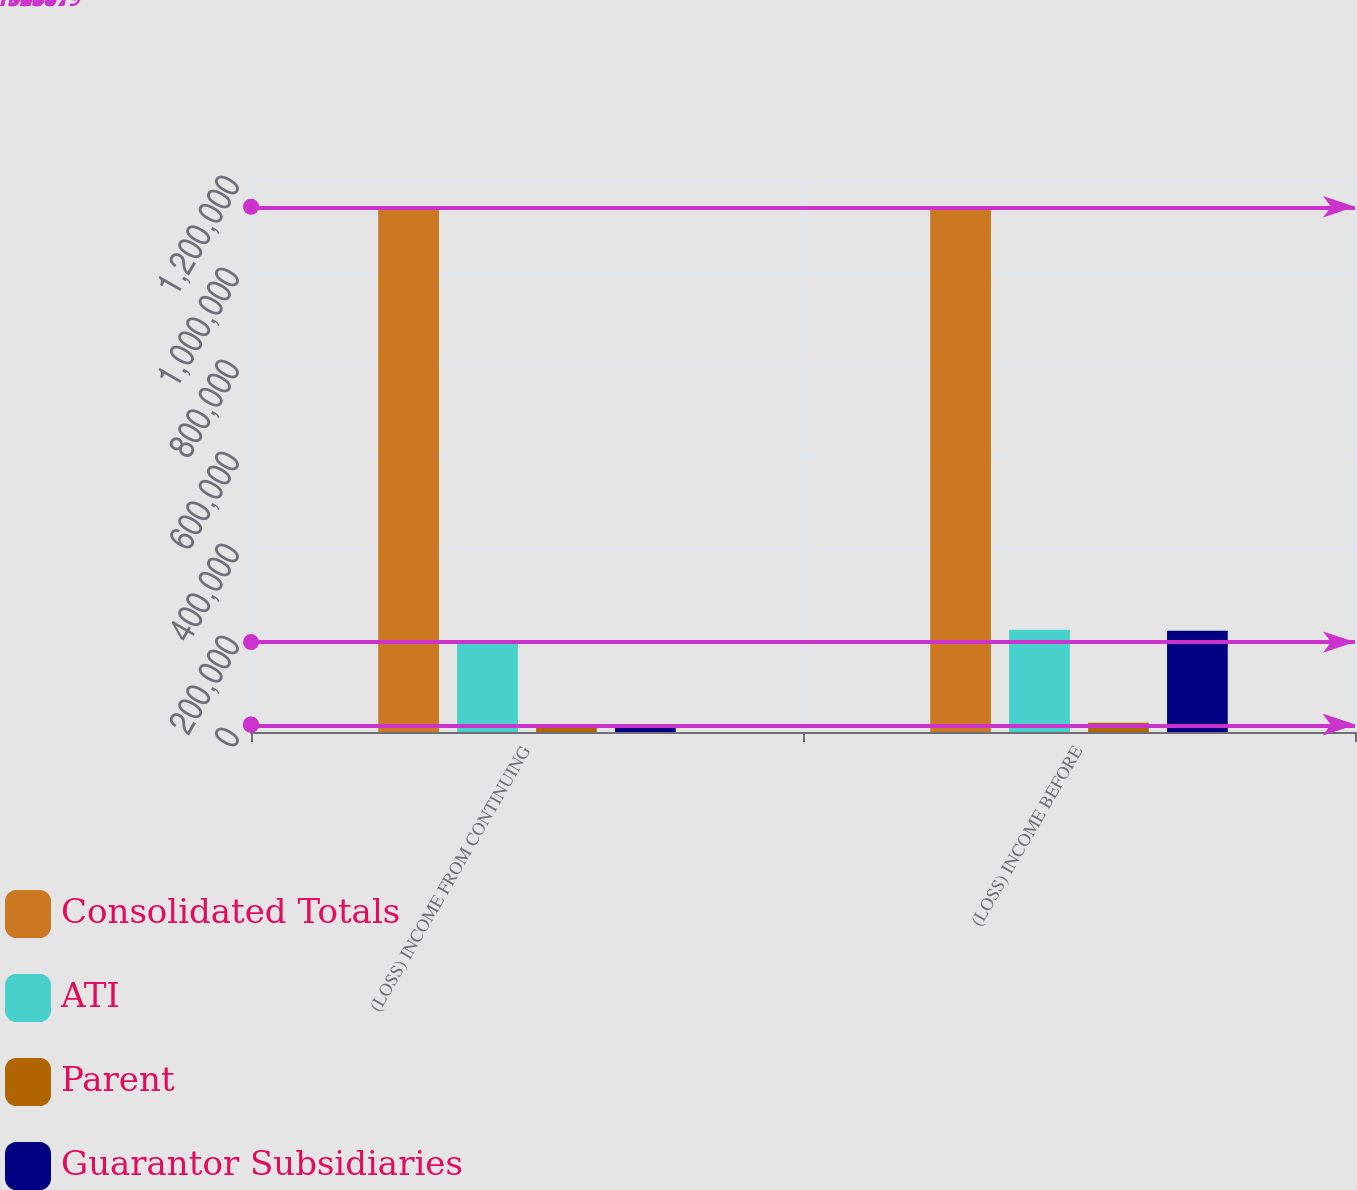Convert chart. <chart><loc_0><loc_0><loc_500><loc_500><stacked_bar_chart><ecel><fcel>(LOSS) INCOME FROM CONTINUING<fcel>(LOSS) INCOME BEFORE<nl><fcel>Consolidated Totals<fcel>1.14188e+06<fcel>1.14188e+06<nl><fcel>ATI<fcel>195441<fcel>222219<nl><fcel>Parent<fcel>15538<fcel>20044<nl><fcel>Guarantor Subsidiaries<fcel>16267<fcel>220185<nl></chart> 